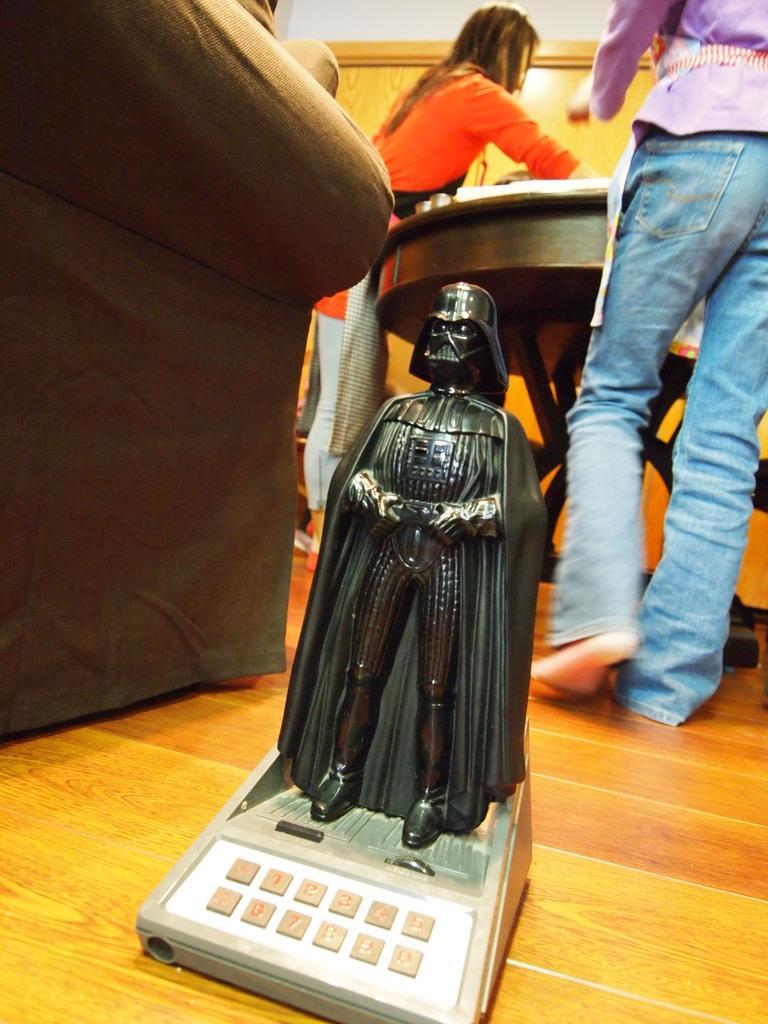Please provide a concise description of this image. In this image in front there is a toy on the floor. Behind the toy there are two people standing in front of the table. On the left side of the image there is a sofa. 